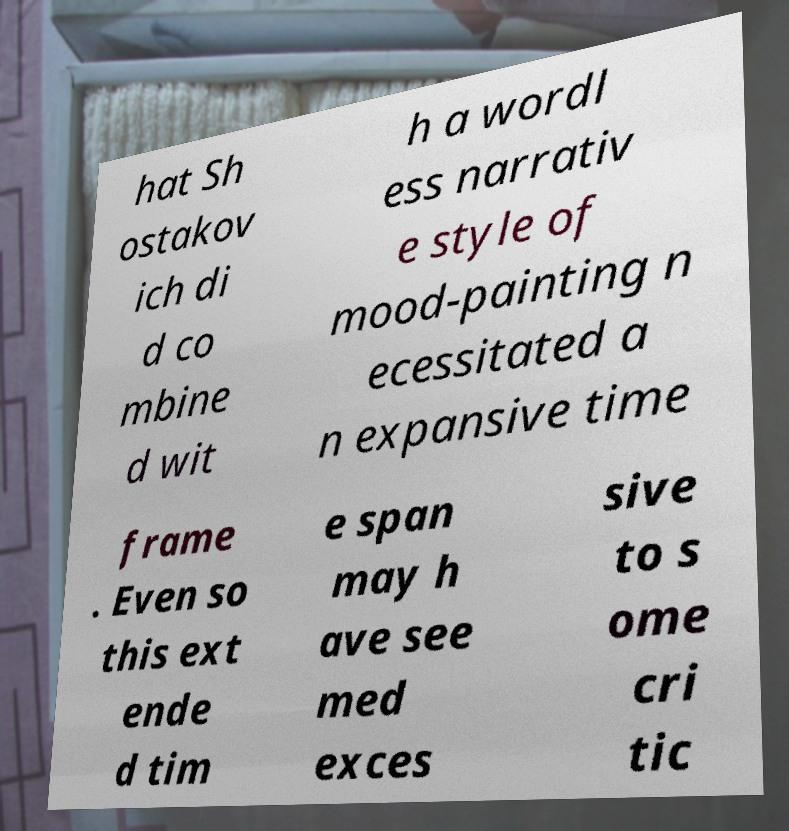I need the written content from this picture converted into text. Can you do that? hat Sh ostakov ich di d co mbine d wit h a wordl ess narrativ e style of mood-painting n ecessitated a n expansive time frame . Even so this ext ende d tim e span may h ave see med exces sive to s ome cri tic 